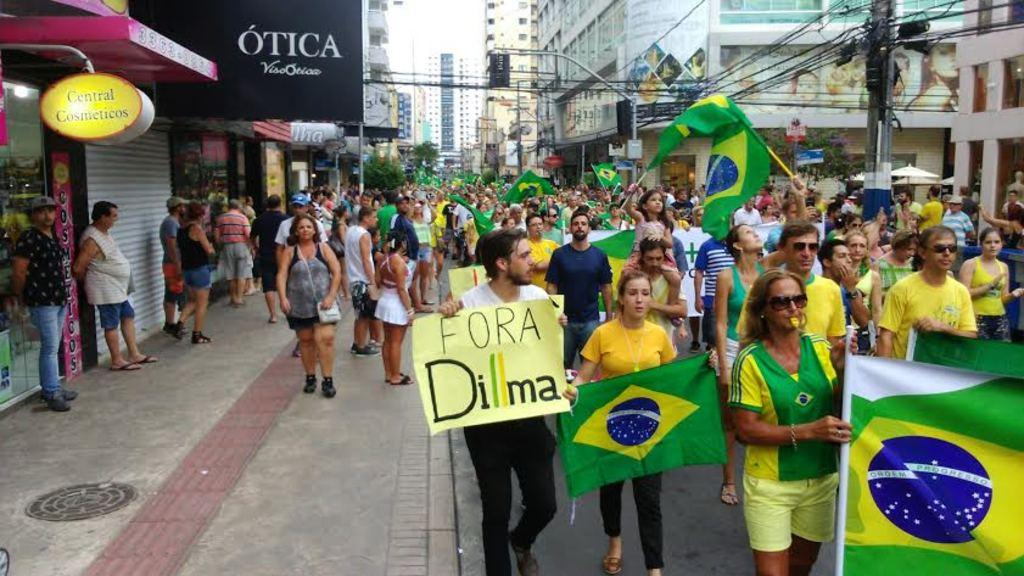What is the main subject of the image? The main subject of the image is a crowd of people. What are some people in the crowd holding? Some people in the crowd are holding flags and posters. What can be seen in the background of the image? In the background of the image, there are buildings, trees, and stores. Can you describe any other objects or structures in the image? Yes, there are boards and a current pole with cables in the image. What word is written on the ladybug's back in the image? There are no ladybugs present in the image, so it is not possible to answer that question. 